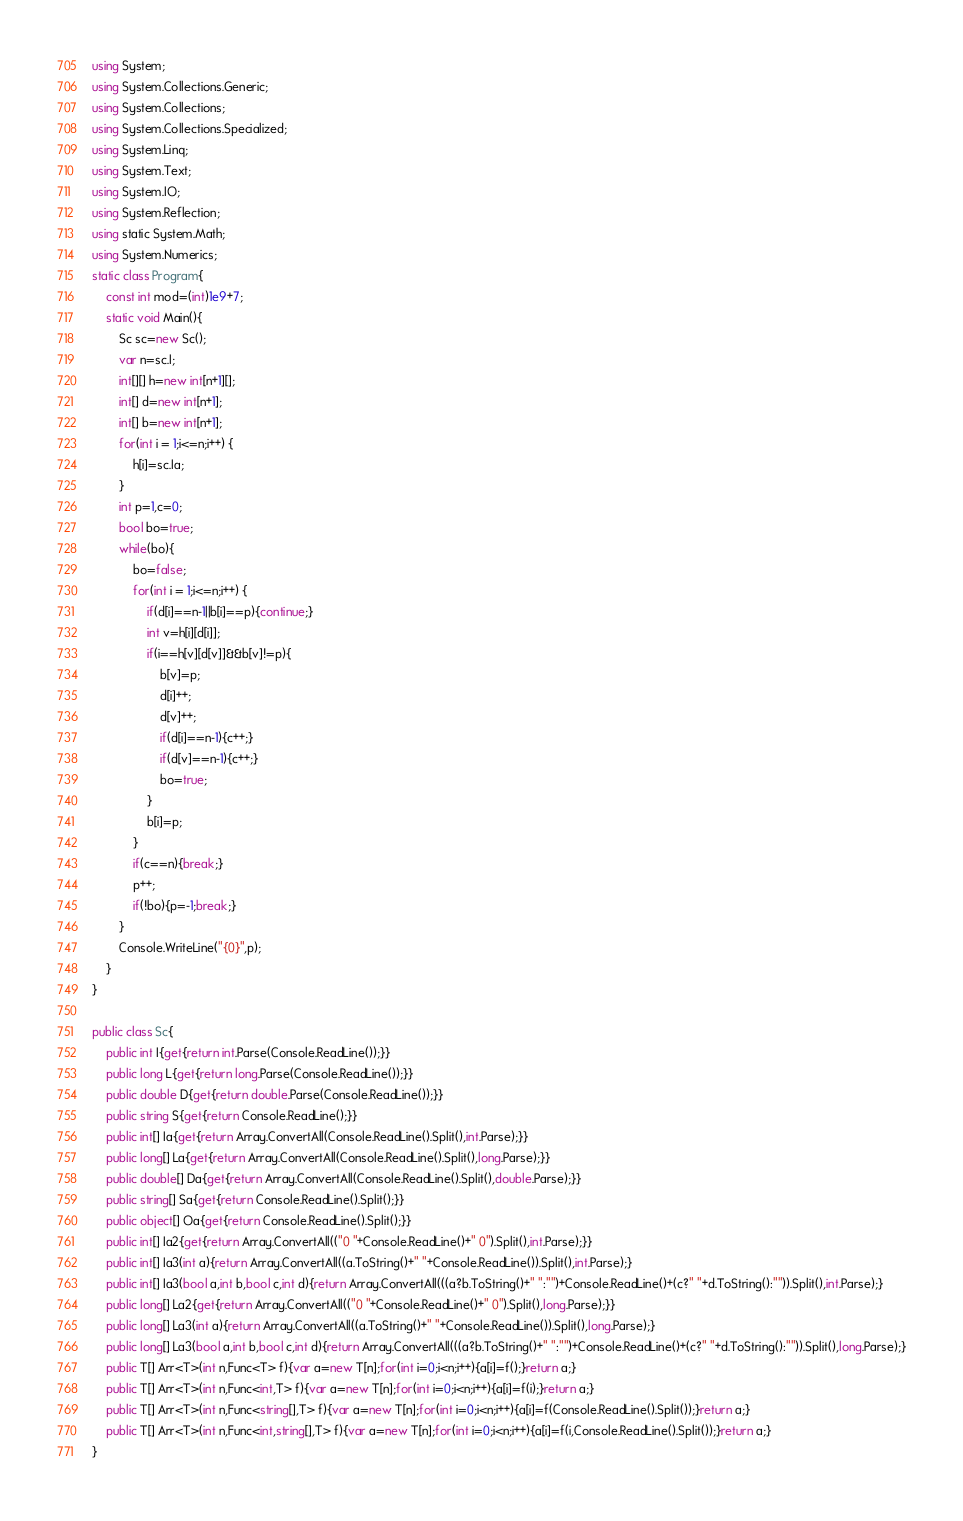Convert code to text. <code><loc_0><loc_0><loc_500><loc_500><_C#_>using System;
using System.Collections.Generic;
using System.Collections;
using System.Collections.Specialized;
using System.Linq;
using System.Text;
using System.IO;
using System.Reflection;
using static System.Math;
using System.Numerics;
static class Program{
	const int mod=(int)1e9+7;
	static void Main(){
		Sc sc=new Sc();
		var n=sc.I;
		int[][] h=new int[n+1][];
		int[] d=new int[n+1];
		int[] b=new int[n+1];
		for(int i = 1;i<=n;i++) {
			h[i]=sc.Ia;
		}
		int p=1,c=0;
		bool bo=true;
		while(bo){
			bo=false;
			for(int i = 1;i<=n;i++) {
				if(d[i]==n-1||b[i]==p){continue;}
				int v=h[i][d[i]];
				if(i==h[v][d[v]]&&b[v]!=p){
					b[v]=p;
					d[i]++;
					d[v]++;
					if(d[i]==n-1){c++;}
					if(d[v]==n-1){c++;}
					bo=true;
				}
				b[i]=p;
			}
			if(c==n){break;}
			p++;
			if(!bo){p=-1;break;}
		}
		Console.WriteLine("{0}",p);
	}
}

public class Sc{
	public int I{get{return int.Parse(Console.ReadLine());}}
	public long L{get{return long.Parse(Console.ReadLine());}}
	public double D{get{return double.Parse(Console.ReadLine());}}
	public string S{get{return Console.ReadLine();}}
	public int[] Ia{get{return Array.ConvertAll(Console.ReadLine().Split(),int.Parse);}}
	public long[] La{get{return Array.ConvertAll(Console.ReadLine().Split(),long.Parse);}}
	public double[] Da{get{return Array.ConvertAll(Console.ReadLine().Split(),double.Parse);}}
	public string[] Sa{get{return Console.ReadLine().Split();}}
	public object[] Oa{get{return Console.ReadLine().Split();}}
	public int[] Ia2{get{return Array.ConvertAll(("0 "+Console.ReadLine()+" 0").Split(),int.Parse);}}
	public int[] Ia3(int a){return Array.ConvertAll((a.ToString()+" "+Console.ReadLine()).Split(),int.Parse);}
	public int[] Ia3(bool a,int b,bool c,int d){return Array.ConvertAll(((a?b.ToString()+" ":"")+Console.ReadLine()+(c?" "+d.ToString():"")).Split(),int.Parse);}
	public long[] La2{get{return Array.ConvertAll(("0 "+Console.ReadLine()+" 0").Split(),long.Parse);}}
	public long[] La3(int a){return Array.ConvertAll((a.ToString()+" "+Console.ReadLine()).Split(),long.Parse);}
	public long[] La3(bool a,int b,bool c,int d){return Array.ConvertAll(((a?b.ToString()+" ":"")+Console.ReadLine()+(c?" "+d.ToString():"")).Split(),long.Parse);}
	public T[] Arr<T>(int n,Func<T> f){var a=new T[n];for(int i=0;i<n;i++){a[i]=f();}return a;}
	public T[] Arr<T>(int n,Func<int,T> f){var a=new T[n];for(int i=0;i<n;i++){a[i]=f(i);}return a;}
	public T[] Arr<T>(int n,Func<string[],T> f){var a=new T[n];for(int i=0;i<n;i++){a[i]=f(Console.ReadLine().Split());}return a;}
	public T[] Arr<T>(int n,Func<int,string[],T> f){var a=new T[n];for(int i=0;i<n;i++){a[i]=f(i,Console.ReadLine().Split());}return a;}
}</code> 